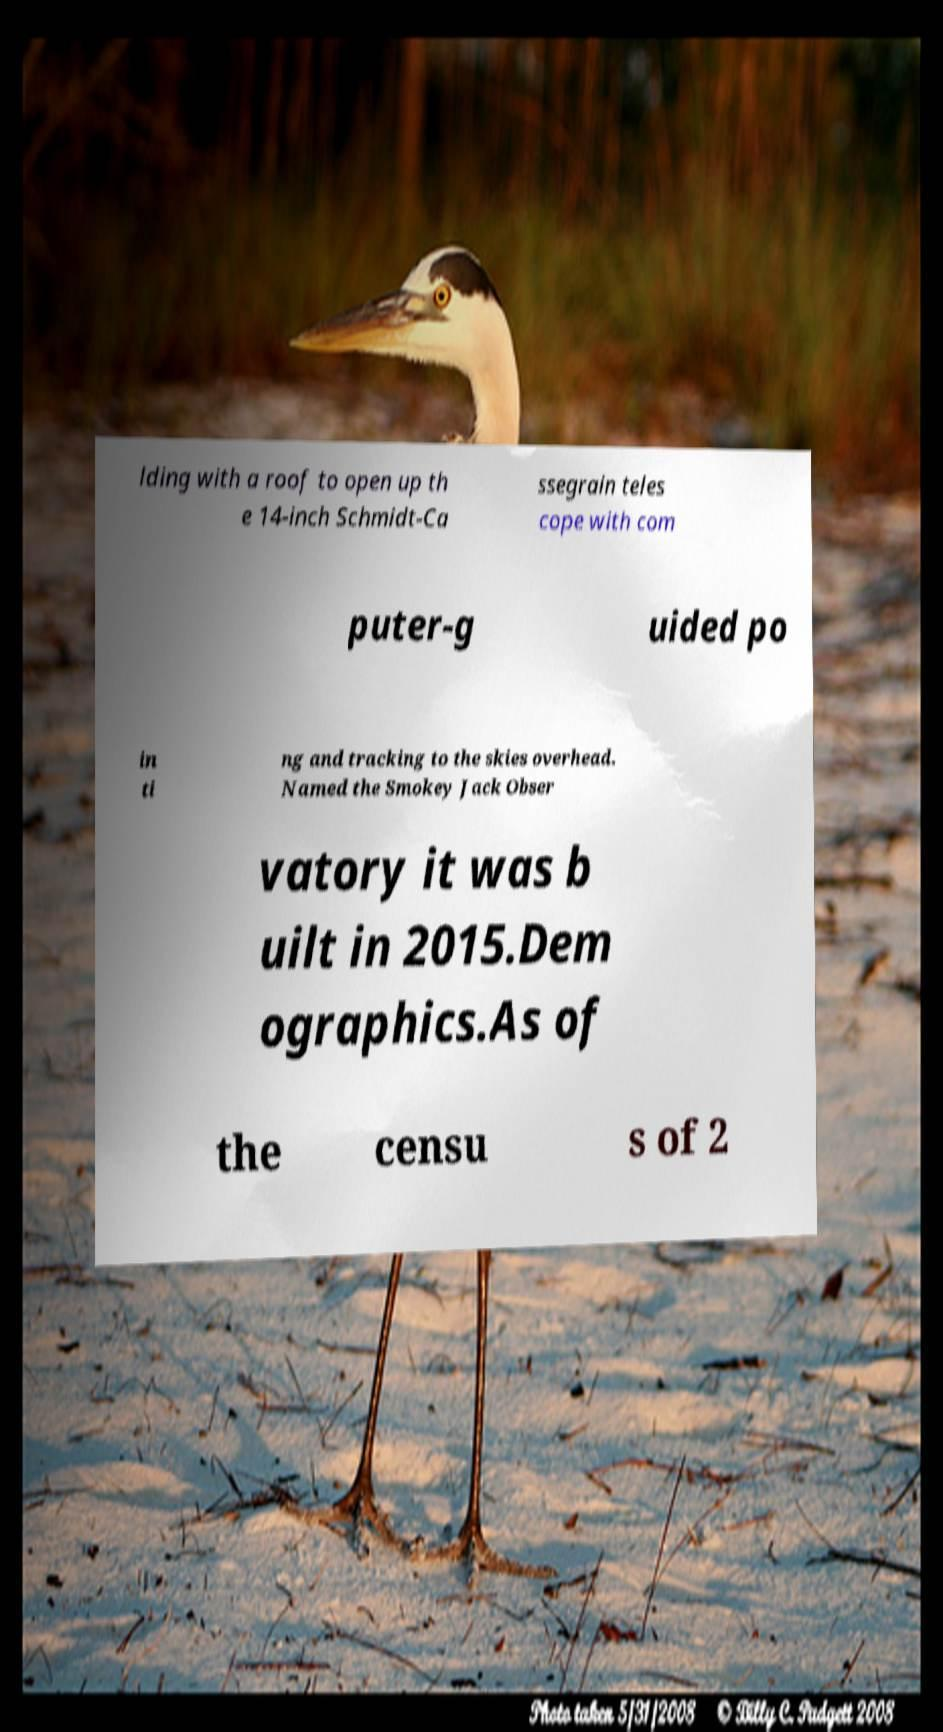Can you accurately transcribe the text from the provided image for me? lding with a roof to open up th e 14-inch Schmidt-Ca ssegrain teles cope with com puter-g uided po in ti ng and tracking to the skies overhead. Named the Smokey Jack Obser vatory it was b uilt in 2015.Dem ographics.As of the censu s of 2 